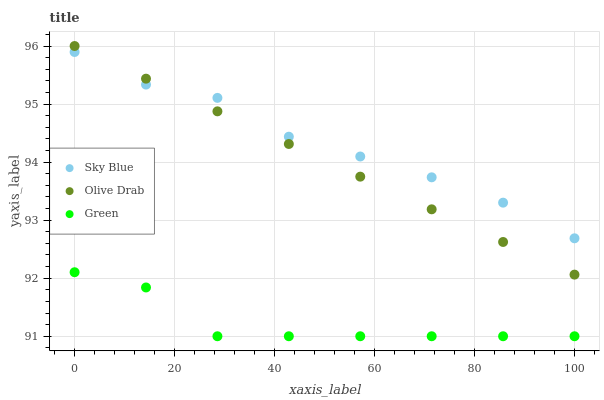Does Green have the minimum area under the curve?
Answer yes or no. Yes. Does Sky Blue have the maximum area under the curve?
Answer yes or no. Yes. Does Olive Drab have the minimum area under the curve?
Answer yes or no. No. Does Olive Drab have the maximum area under the curve?
Answer yes or no. No. Is Olive Drab the smoothest?
Answer yes or no. Yes. Is Green the roughest?
Answer yes or no. Yes. Is Green the smoothest?
Answer yes or no. No. Is Olive Drab the roughest?
Answer yes or no. No. Does Green have the lowest value?
Answer yes or no. Yes. Does Olive Drab have the lowest value?
Answer yes or no. No. Does Olive Drab have the highest value?
Answer yes or no. Yes. Does Green have the highest value?
Answer yes or no. No. Is Green less than Sky Blue?
Answer yes or no. Yes. Is Olive Drab greater than Green?
Answer yes or no. Yes. Does Olive Drab intersect Sky Blue?
Answer yes or no. Yes. Is Olive Drab less than Sky Blue?
Answer yes or no. No. Is Olive Drab greater than Sky Blue?
Answer yes or no. No. Does Green intersect Sky Blue?
Answer yes or no. No. 